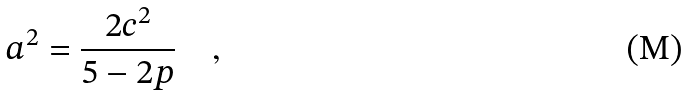Convert formula to latex. <formula><loc_0><loc_0><loc_500><loc_500>a ^ { 2 } = \frac { 2 c ^ { 2 } } { 5 - 2 p } \quad ,</formula> 